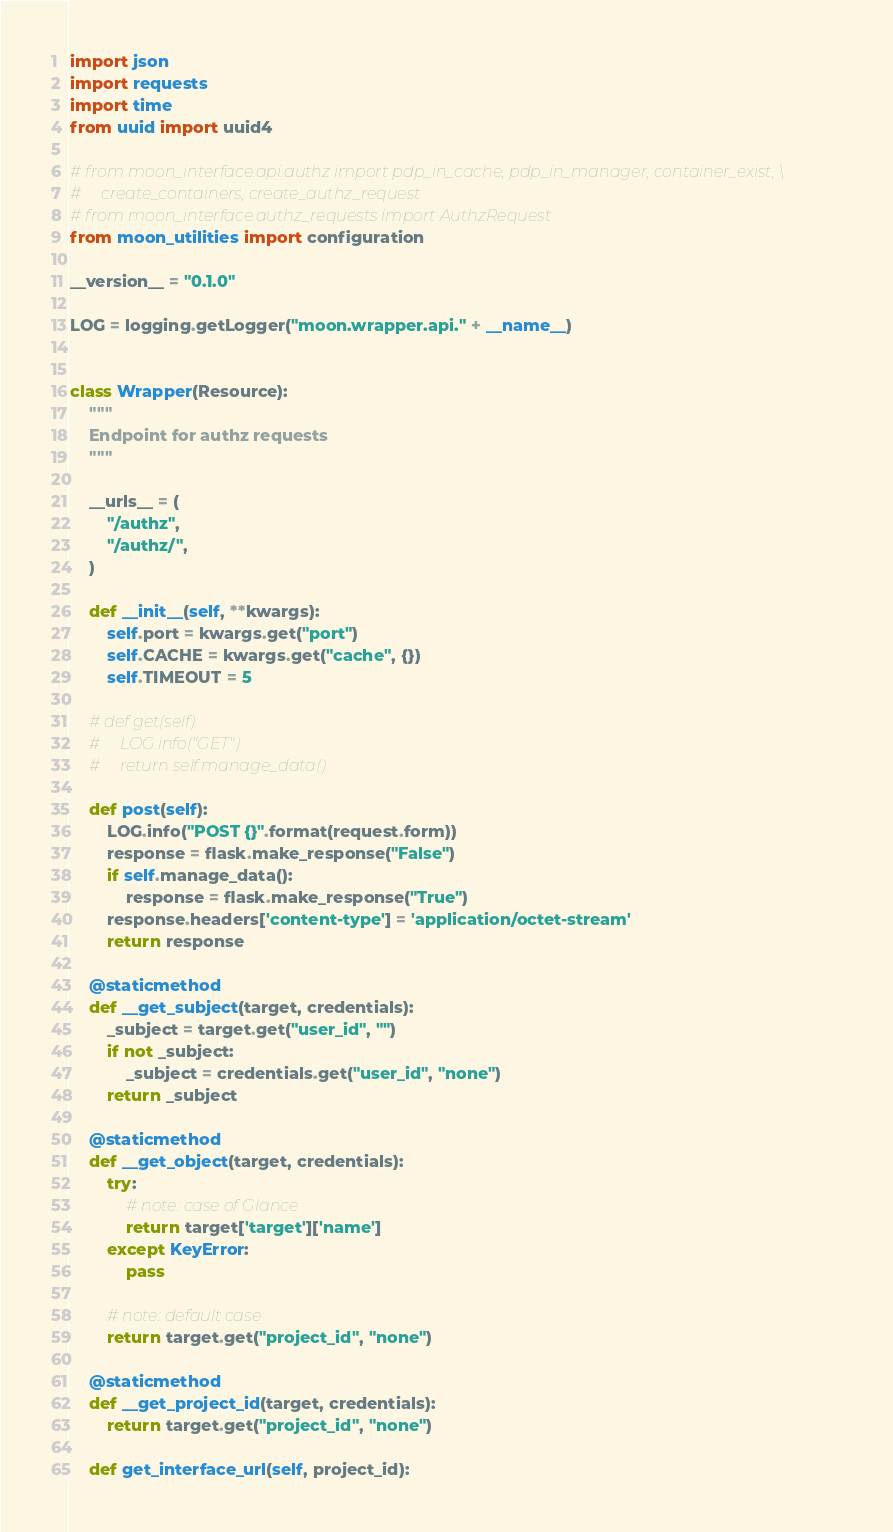Convert code to text. <code><loc_0><loc_0><loc_500><loc_500><_Python_>import json
import requests
import time
from uuid import uuid4

# from moon_interface.api.authz import pdp_in_cache, pdp_in_manager, container_exist, \
#     create_containers, create_authz_request
# from moon_interface.authz_requests import AuthzRequest
from moon_utilities import configuration

__version__ = "0.1.0"

LOG = logging.getLogger("moon.wrapper.api." + __name__)


class Wrapper(Resource):
    """
    Endpoint for authz requests
    """

    __urls__ = (
        "/authz",
        "/authz/",
    )

    def __init__(self, **kwargs):
        self.port = kwargs.get("port")
        self.CACHE = kwargs.get("cache", {})
        self.TIMEOUT = 5

    # def get(self):
    #     LOG.info("GET")
    #     return self.manage_data()

    def post(self):
        LOG.info("POST {}".format(request.form))
        response = flask.make_response("False")
        if self.manage_data():
            response = flask.make_response("True")
        response.headers['content-type'] = 'application/octet-stream'
        return response

    @staticmethod
    def __get_subject(target, credentials):
        _subject = target.get("user_id", "")
        if not _subject:
            _subject = credentials.get("user_id", "none")
        return _subject

    @staticmethod
    def __get_object(target, credentials):
        try:
            # note: case of Glance
            return target['target']['name']
        except KeyError:
            pass

        # note: default case
        return target.get("project_id", "none")

    @staticmethod
    def __get_project_id(target, credentials):
        return target.get("project_id", "none")

    def get_interface_url(self, project_id):</code> 